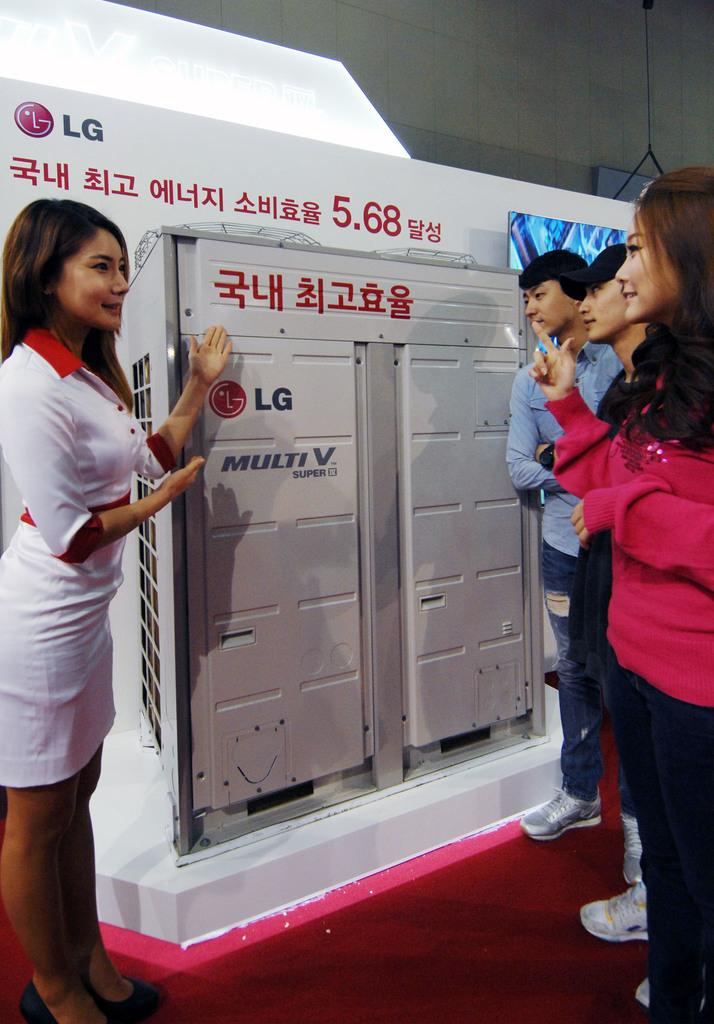<image>
Provide a brief description of the given image. A woman is showing a LG brand device to some consumers. 